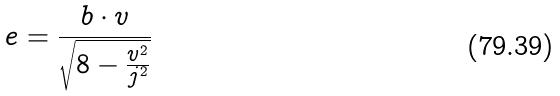Convert formula to latex. <formula><loc_0><loc_0><loc_500><loc_500>e = \frac { b \cdot v } { \sqrt { 8 - \frac { v ^ { 2 } } { j ^ { 2 } } } }</formula> 